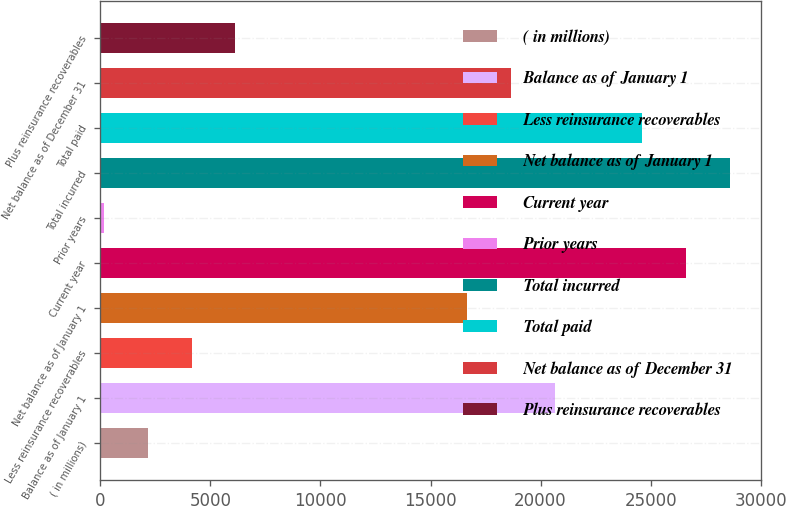Convert chart. <chart><loc_0><loc_0><loc_500><loc_500><bar_chart><fcel>( in millions)<fcel>Balance as of January 1<fcel>Less reinsurance recoverables<fcel>Net balance as of January 1<fcel>Current year<fcel>Prior years<fcel>Total incurred<fcel>Total paid<fcel>Net balance as of December 31<fcel>Plus reinsurance recoverables<nl><fcel>2159.4<fcel>20638.8<fcel>4148.8<fcel>16660<fcel>26607<fcel>170<fcel>28596.4<fcel>24617.6<fcel>18649.4<fcel>6138.2<nl></chart> 